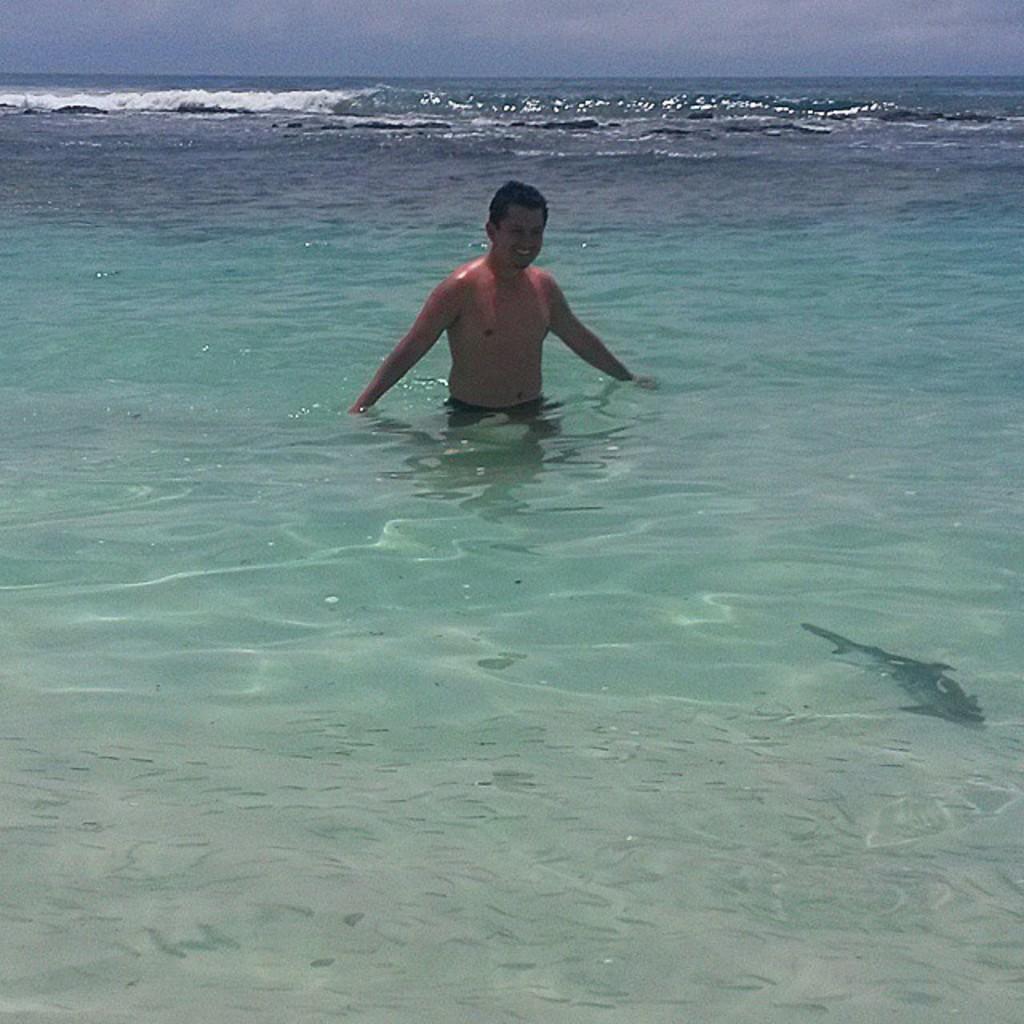Describe this image in one or two sentences. In this image, we can see water there is a man standing in the water, at the top there is a sky. 